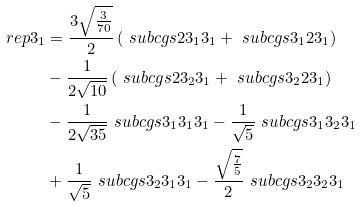Convert formula to latex. <formula><loc_0><loc_0><loc_500><loc_500>\ r e p { 3 } _ { 1 } & = \frac { 3 \sqrt { \frac { 3 } { 7 0 } } } { 2 } \left ( \ s u b c g s { 2 } { 3 _ { 1 } } { 3 _ { 1 } } + \ s u b c g s { 3 _ { 1 } } { 2 } { 3 _ { 1 } } \right ) \\ & - \frac { 1 } { 2 \sqrt { 1 0 } } \left ( \ s u b c g s { 2 } { 3 _ { 2 } } { 3 _ { 1 } } + \ s u b c g s { 3 _ { 2 } } { 2 } { 3 _ { 1 } } \right ) \\ & - \frac { 1 } { 2 \sqrt { 3 5 } } \ s u b c g s { 3 _ { 1 } } { 3 _ { 1 } } { 3 _ { 1 } } - \frac { 1 } { \sqrt { 5 } } \ s u b c g s { 3 _ { 1 } } { 3 _ { 2 } } { 3 _ { 1 } } \\ & + \frac { 1 } { \sqrt { 5 } } \ s u b c g s { 3 _ { 2 } } { 3 _ { 1 } } { 3 _ { 1 } } - \frac { \sqrt { \frac { 7 } { 5 } } } { 2 } \ s u b c g s { 3 _ { 2 } } { 3 _ { 2 } } { 3 _ { 1 } }</formula> 